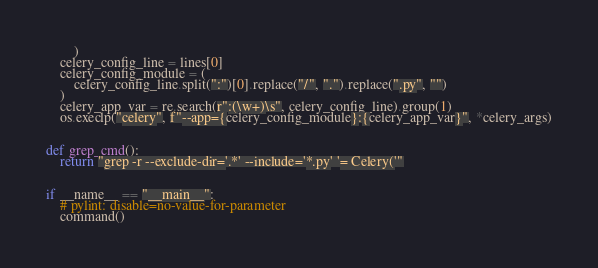Convert code to text. <code><loc_0><loc_0><loc_500><loc_500><_Python_>        )
    celery_config_line = lines[0]
    celery_config_module = (
        celery_config_line.split(":")[0].replace("/", ".").replace(".py", "")
    )
    celery_app_var = re.search(r":(\w+)\s", celery_config_line).group(1)
    os.execlp("celery", f"--app={celery_config_module}:{celery_app_var}", *celery_args)


def grep_cmd():
    return "grep -r --exclude-dir='.*' --include='*.py' '= Celery('"


if __name__ == "__main__":
    # pylint: disable=no-value-for-parameter
    command()
</code> 